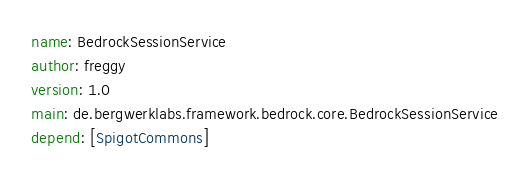Convert code to text. <code><loc_0><loc_0><loc_500><loc_500><_YAML_>name: BedrockSessionService
author: freggy
version: 1.0
main: de.bergwerklabs.framework.bedrock.core.BedrockSessionService
depend: [SpigotCommons]</code> 